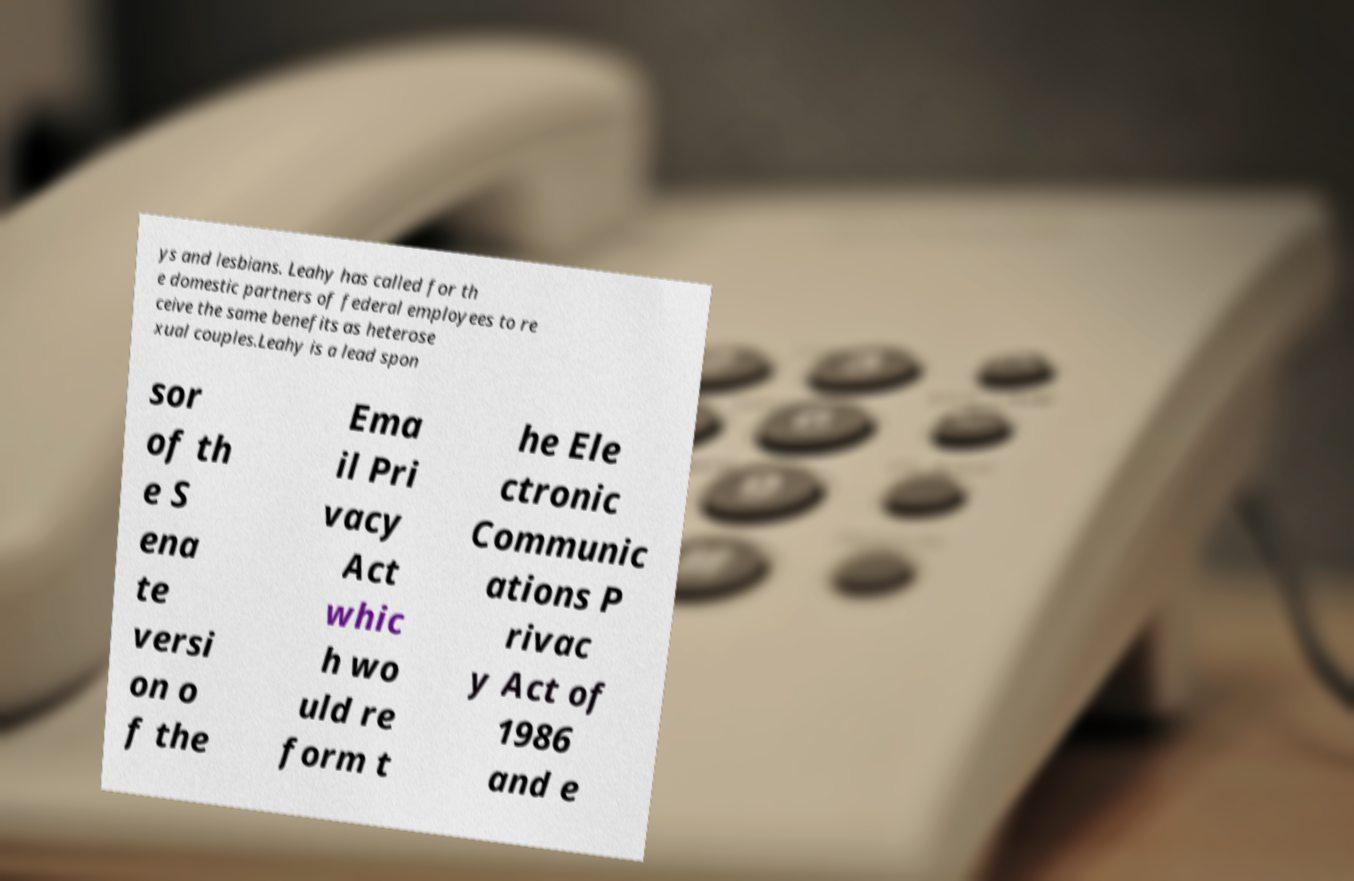Can you accurately transcribe the text from the provided image for me? ys and lesbians. Leahy has called for th e domestic partners of federal employees to re ceive the same benefits as heterose xual couples.Leahy is a lead spon sor of th e S ena te versi on o f the Ema il Pri vacy Act whic h wo uld re form t he Ele ctronic Communic ations P rivac y Act of 1986 and e 